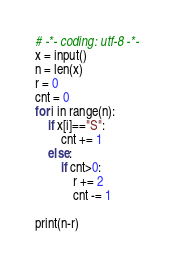Convert code to text. <code><loc_0><loc_0><loc_500><loc_500><_Python_># -*- coding: utf-8 -*-
x = input()
n = len(x)
r = 0
cnt = 0
for i in range(n):
    if x[i]=="S":
        cnt += 1
    else:
        if cnt>0:
            r += 2
            cnt -= 1

print(n-r)
</code> 